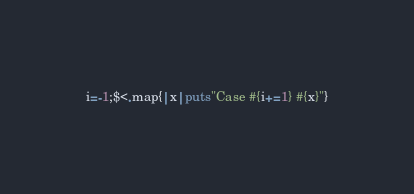Convert code to text. <code><loc_0><loc_0><loc_500><loc_500><_Ruby_>i=-1;$<.map{|x|puts"Case #{i+=1} #{x}"}</code> 